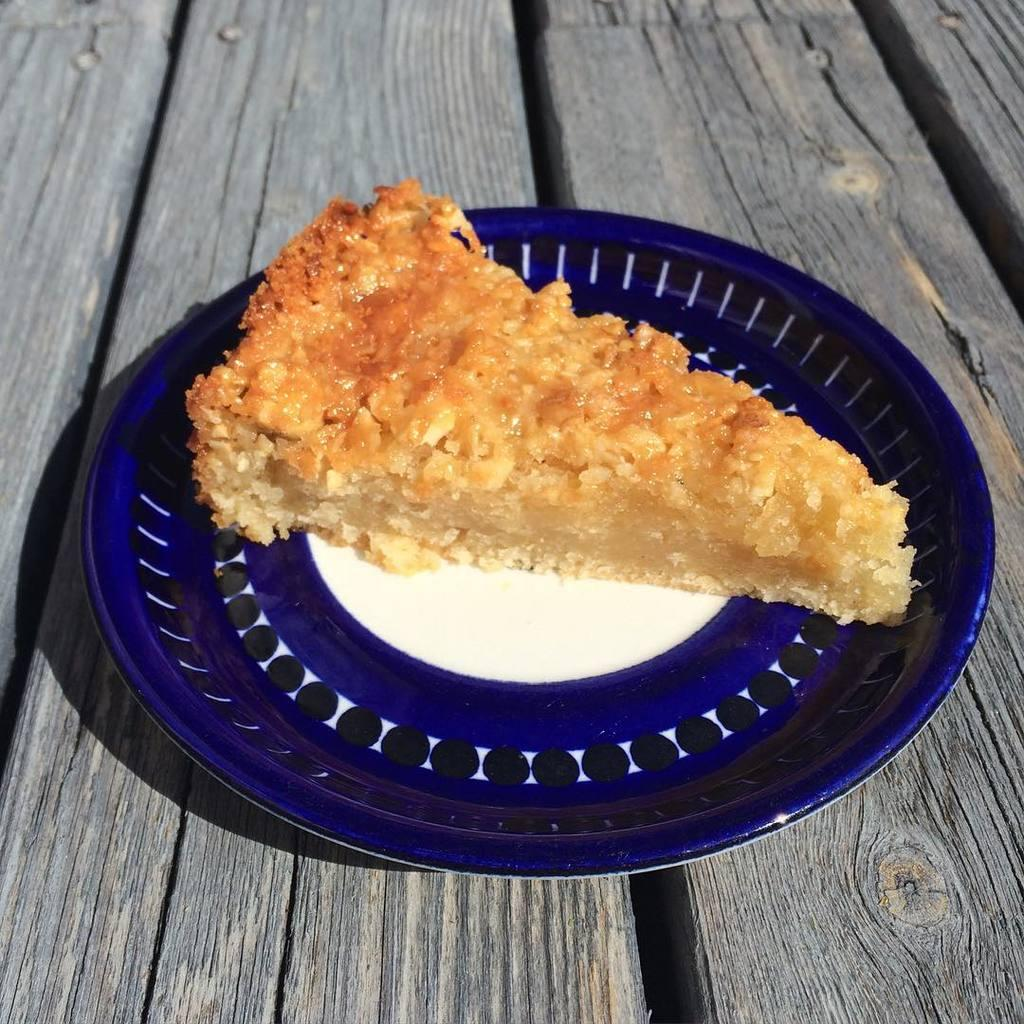What is on the plate that is visible in the image? There is a food item on a plate in the image. Where is the plate located in the image? The plate is on a table in the image. What type of note is attached to the food item in the image? There is no note attached to the food item in the image. 